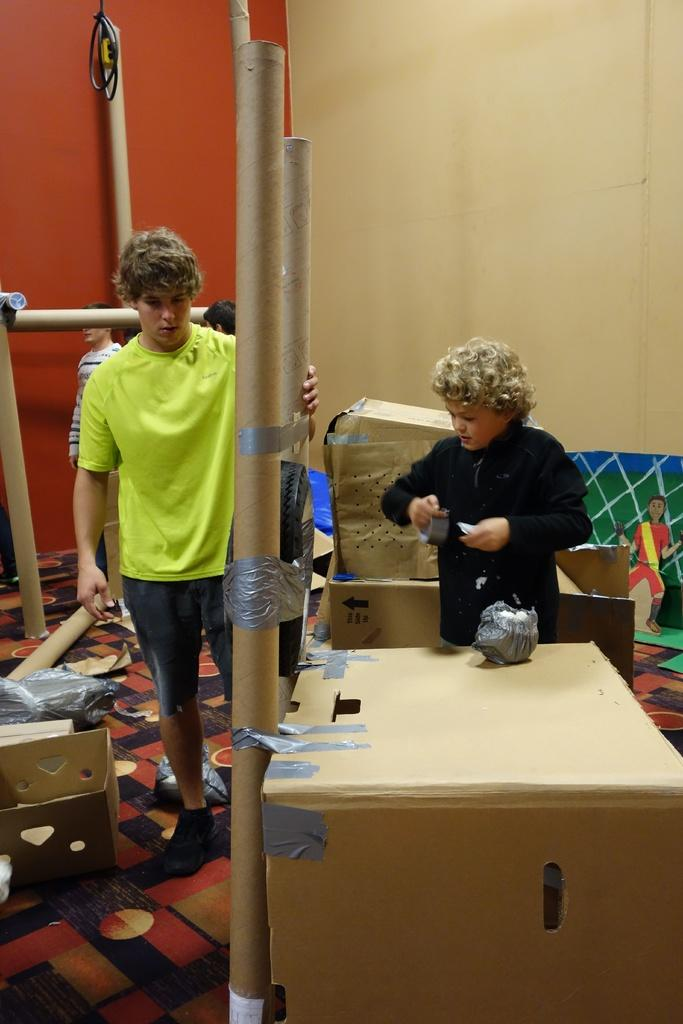How many people are visible in the image? There are two persons standing in the image. What are the two persons holding? The two persons are holding an object. What can be seen around the two persons? There are wooden boxes around the two persons. Are there any other people visible in the image? Yes, there are additional persons standing in the background of the image. What type of punishment is being administered to the persons in the image? There is no indication of punishment in the image; the two persons are simply holding an object. 